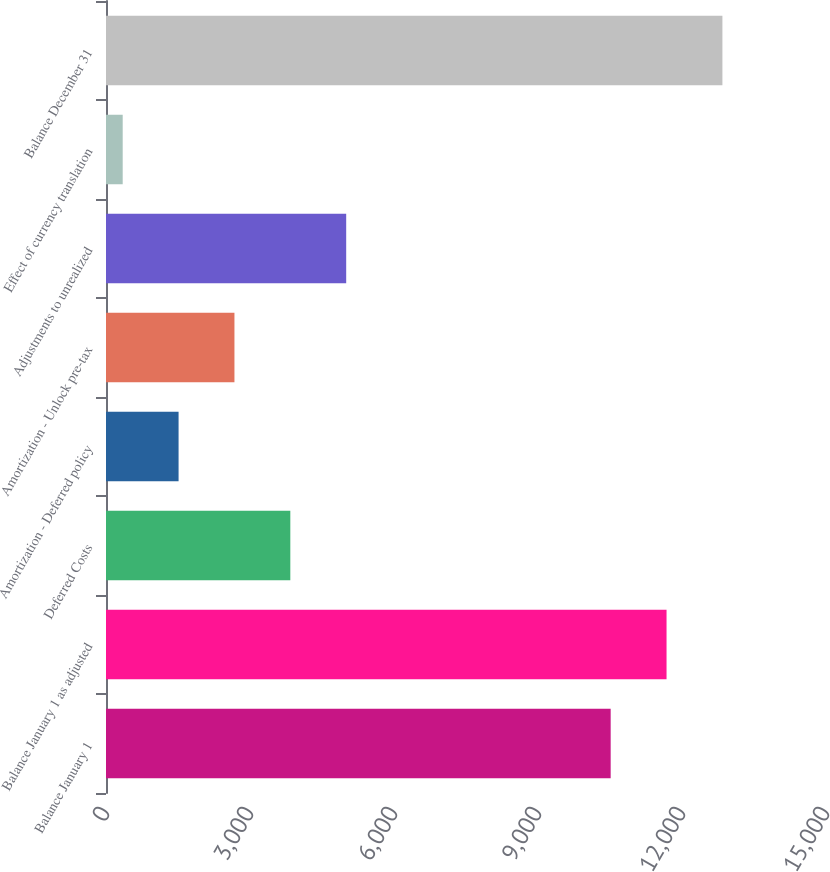<chart> <loc_0><loc_0><loc_500><loc_500><bar_chart><fcel>Balance January 1<fcel>Balance January 1 as adjusted<fcel>Deferred Costs<fcel>Amortization - Deferred policy<fcel>Amortization - Unlock pre-tax<fcel>Adjustments to unrealized<fcel>Effect of currency translation<fcel>Balance December 31<nl><fcel>10514<fcel>11678<fcel>3840<fcel>1512<fcel>2676<fcel>5004<fcel>348<fcel>12842<nl></chart> 